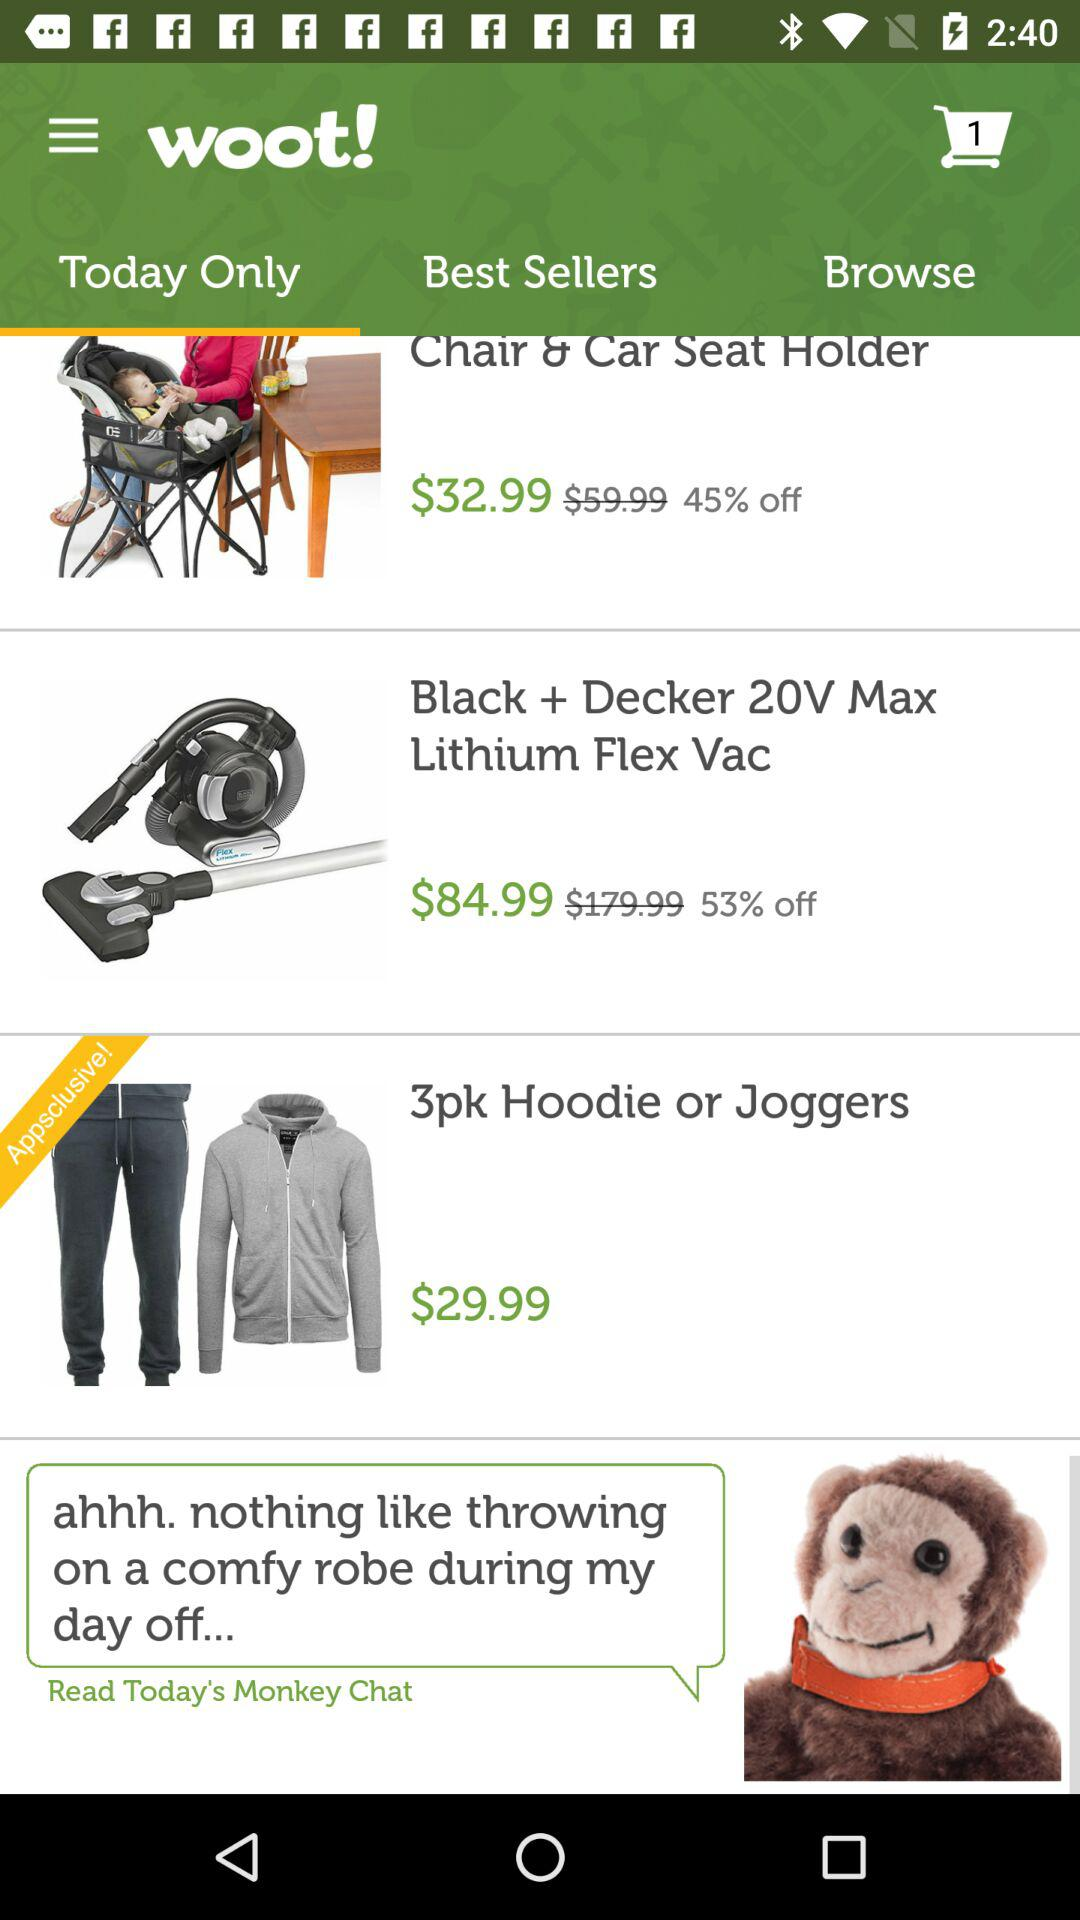What is the price of "Chair & Car Seat Holder" after the discount? The price is $32.99. 